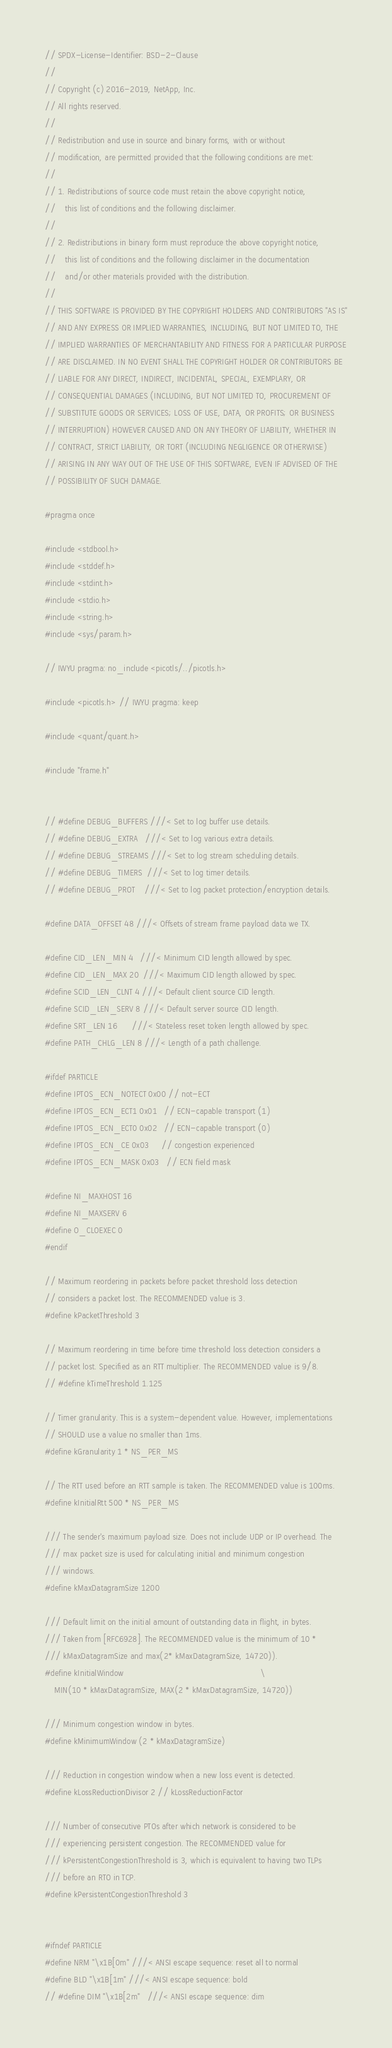<code> <loc_0><loc_0><loc_500><loc_500><_C_>// SPDX-License-Identifier: BSD-2-Clause
//
// Copyright (c) 2016-2019, NetApp, Inc.
// All rights reserved.
//
// Redistribution and use in source and binary forms, with or without
// modification, are permitted provided that the following conditions are met:
//
// 1. Redistributions of source code must retain the above copyright notice,
//    this list of conditions and the following disclaimer.
//
// 2. Redistributions in binary form must reproduce the above copyright notice,
//    this list of conditions and the following disclaimer in the documentation
//    and/or other materials provided with the distribution.
//
// THIS SOFTWARE IS PROVIDED BY THE COPYRIGHT HOLDERS AND CONTRIBUTORS "AS IS"
// AND ANY EXPRESS OR IMPLIED WARRANTIES, INCLUDING, BUT NOT LIMITED TO, THE
// IMPLIED WARRANTIES OF MERCHANTABILITY AND FITNESS FOR A PARTICULAR PURPOSE
// ARE DISCLAIMED. IN NO EVENT SHALL THE COPYRIGHT HOLDER OR CONTRIBUTORS BE
// LIABLE FOR ANY DIRECT, INDIRECT, INCIDENTAL, SPECIAL, EXEMPLARY, OR
// CONSEQUENTIAL DAMAGES (INCLUDING, BUT NOT LIMITED TO, PROCUREMENT OF
// SUBSTITUTE GOODS OR SERVICES; LOSS OF USE, DATA, OR PROFITS; OR BUSINESS
// INTERRUPTION) HOWEVER CAUSED AND ON ANY THEORY OF LIABILITY, WHETHER IN
// CONTRACT, STRICT LIABILITY, OR TORT (INCLUDING NEGLIGENCE OR OTHERWISE)
// ARISING IN ANY WAY OUT OF THE USE OF THIS SOFTWARE, EVEN IF ADVISED OF THE
// POSSIBILITY OF SUCH DAMAGE.

#pragma once

#include <stdbool.h>
#include <stddef.h>
#include <stdint.h>
#include <stdio.h>
#include <string.h>
#include <sys/param.h>

// IWYU pragma: no_include <picotls/../picotls.h>

#include <picotls.h> // IWYU pragma: keep

#include <quant/quant.h>

#include "frame.h"


// #define DEBUG_BUFFERS ///< Set to log buffer use details.
// #define DEBUG_EXTRA   ///< Set to log various extra details.
// #define DEBUG_STREAMS ///< Set to log stream scheduling details.
// #define DEBUG_TIMERS  ///< Set to log timer details.
// #define DEBUG_PROT    ///< Set to log packet protection/encryption details.

#define DATA_OFFSET 48 ///< Offsets of stream frame payload data we TX.

#define CID_LEN_MIN 4   ///< Minimum CID length allowed by spec.
#define CID_LEN_MAX 20  ///< Maximum CID length allowed by spec.
#define SCID_LEN_CLNT 4 ///< Default client source CID length.
#define SCID_LEN_SERV 8 ///< Default server source CID length.
#define SRT_LEN 16      ///< Stateless reset token length allowed by spec.
#define PATH_CHLG_LEN 8 ///< Length of a path challenge.

#ifdef PARTICLE
#define IPTOS_ECN_NOTECT 0x00 // not-ECT
#define IPTOS_ECN_ECT1 0x01   // ECN-capable transport (1)
#define IPTOS_ECN_ECT0 0x02   // ECN-capable transport (0)
#define IPTOS_ECN_CE 0x03     // congestion experienced
#define IPTOS_ECN_MASK 0x03   // ECN field mask

#define NI_MAXHOST 16
#define NI_MAXSERV 6
#define O_CLOEXEC 0
#endif

// Maximum reordering in packets before packet threshold loss detection
// considers a packet lost. The RECOMMENDED value is 3.
#define kPacketThreshold 3

// Maximum reordering in time before time threshold loss detection considers a
// packet lost. Specified as an RTT multiplier. The RECOMMENDED value is 9/8.
// #define kTimeThreshold 1.125

// Timer granularity. This is a system-dependent value. However, implementations
// SHOULD use a value no smaller than 1ms.
#define kGranularity 1 * NS_PER_MS

// The RTT used before an RTT sample is taken. The RECOMMENDED value is 100ms.
#define kInitialRtt 500 * NS_PER_MS

/// The sender's maximum payload size. Does not include UDP or IP overhead. The
/// max packet size is used for calculating initial and minimum congestion
/// windows.
#define kMaxDatagramSize 1200

/// Default limit on the initial amount of outstanding data in flight, in bytes.
/// Taken from [RFC6928]. The RECOMMENDED value is the minimum of 10 *
/// kMaxDatagramSize and max(2* kMaxDatagramSize, 14720)).
#define kInitialWindow                                                         \
    MIN(10 * kMaxDatagramSize, MAX(2 * kMaxDatagramSize, 14720))

/// Minimum congestion window in bytes.
#define kMinimumWindow (2 * kMaxDatagramSize)

/// Reduction in congestion window when a new loss event is detected.
#define kLossReductionDivisor 2 // kLossReductionFactor

/// Number of consecutive PTOs after which network is considered to be
/// experiencing persistent congestion. The RECOMMENDED value for
/// kPersistentCongestionThreshold is 3, which is equivalent to having two TLPs
/// before an RTO in TCP.
#define kPersistentCongestionThreshold 3


#ifndef PARTICLE
#define NRM "\x1B[0m" ///< ANSI escape sequence: reset all to normal
#define BLD "\x1B[1m" ///< ANSI escape sequence: bold
// #define DIM "\x1B[2m"   ///< ANSI escape sequence: dim</code> 